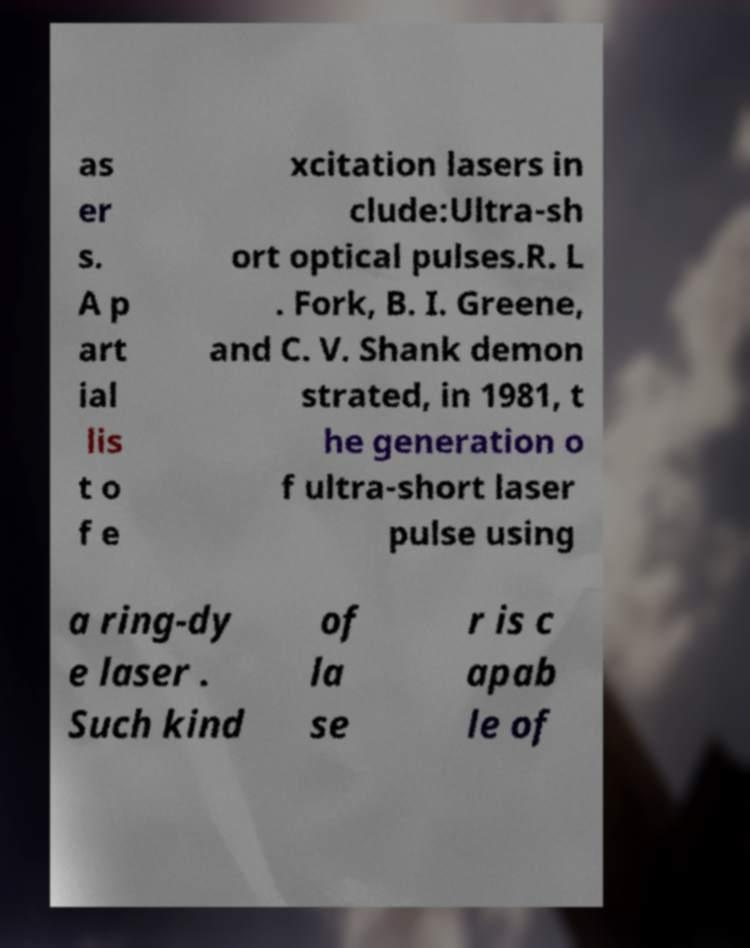Please identify and transcribe the text found in this image. as er s. A p art ial lis t o f e xcitation lasers in clude:Ultra-sh ort optical pulses.R. L . Fork, B. I. Greene, and C. V. Shank demon strated, in 1981, t he generation o f ultra-short laser pulse using a ring-dy e laser . Such kind of la se r is c apab le of 